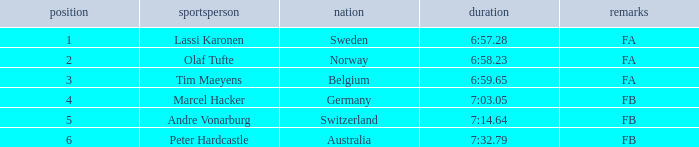What is the lowest rank for Andre Vonarburg, when the notes are FB? 5.0. 